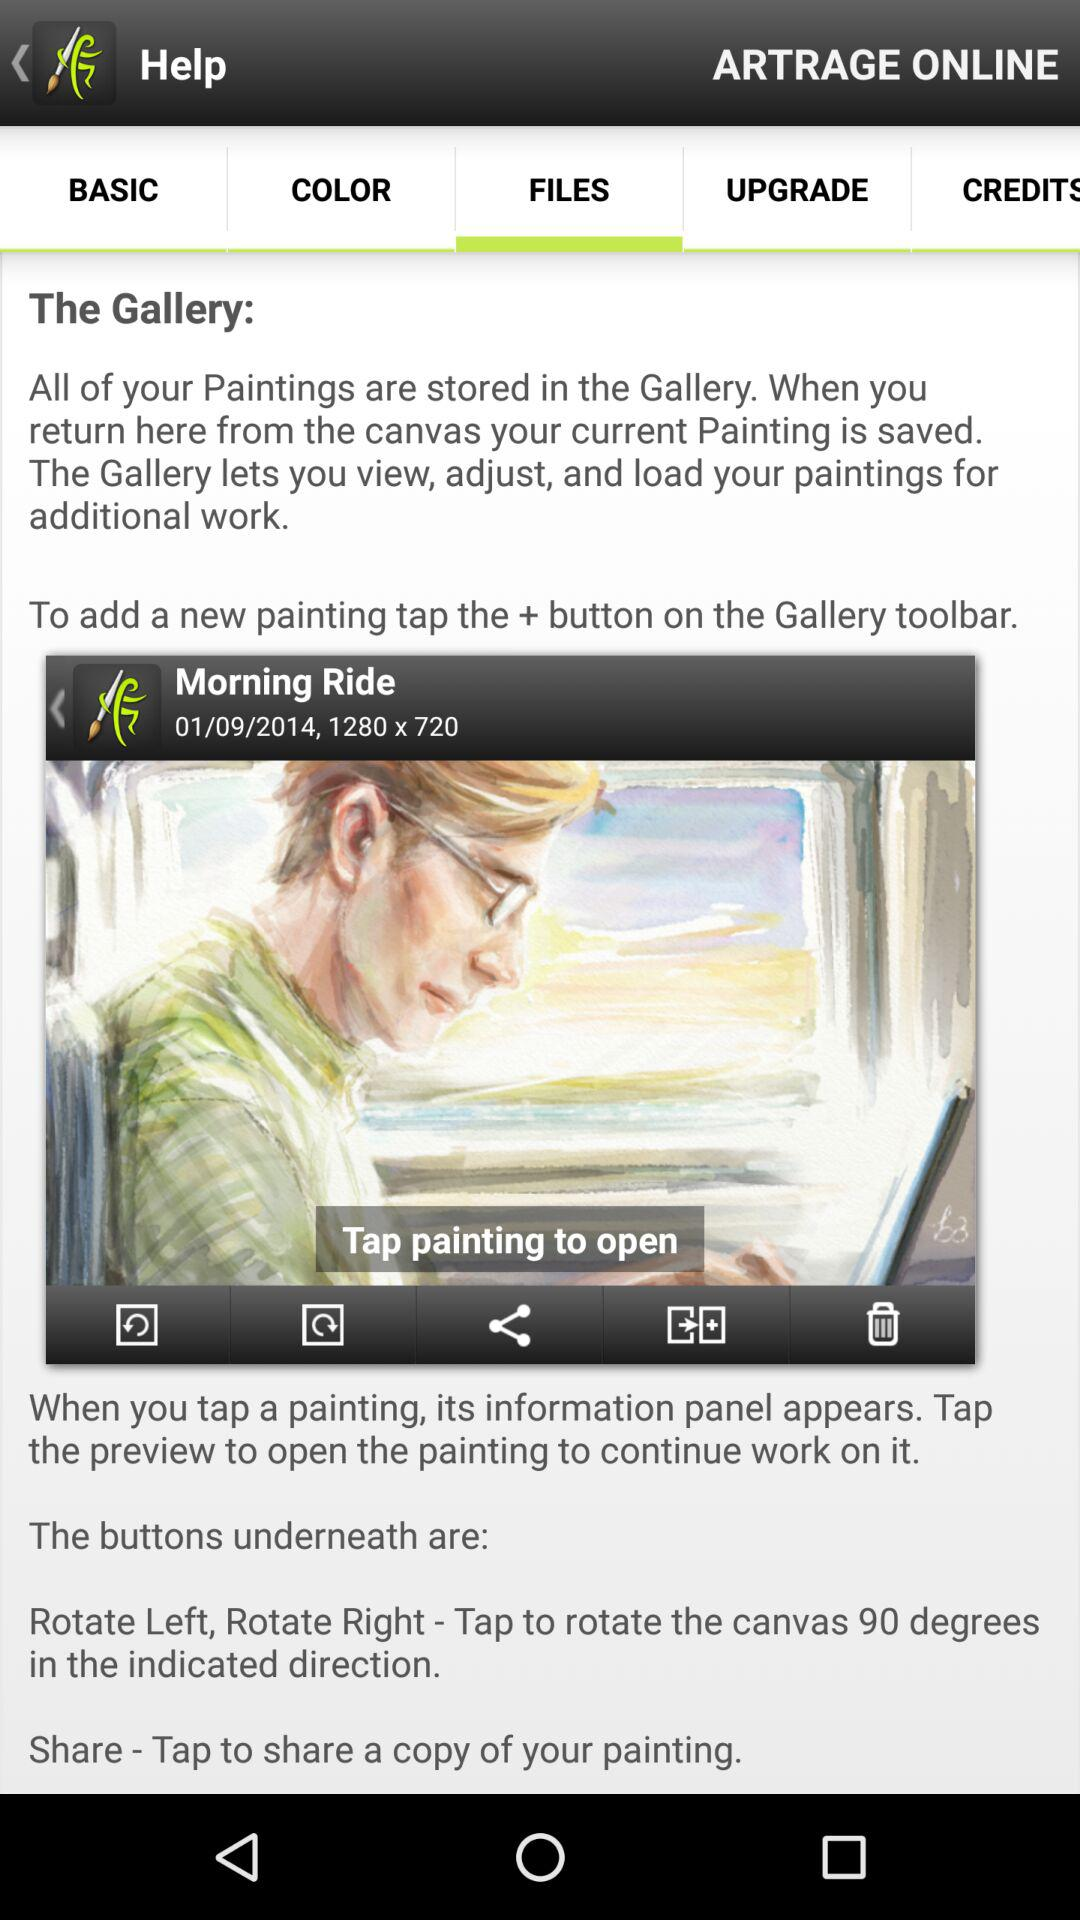How many painting titles are displayed in the gallery?
Answer the question using a single word or phrase. 1 